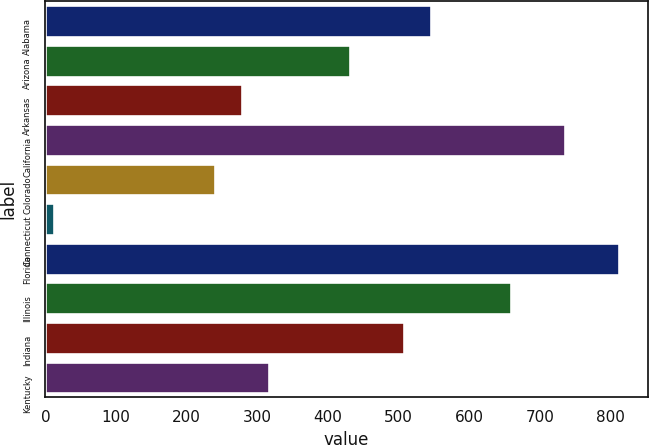Convert chart to OTSL. <chart><loc_0><loc_0><loc_500><loc_500><bar_chart><fcel>Alabama<fcel>Arizona<fcel>Arkansas<fcel>California<fcel>Colorado<fcel>Connecticut<fcel>Florida<fcel>Illinois<fcel>Indiana<fcel>Kentucky<nl><fcel>545.4<fcel>431.1<fcel>278.7<fcel>735.9<fcel>240.6<fcel>12<fcel>812.1<fcel>659.7<fcel>507.3<fcel>316.8<nl></chart> 